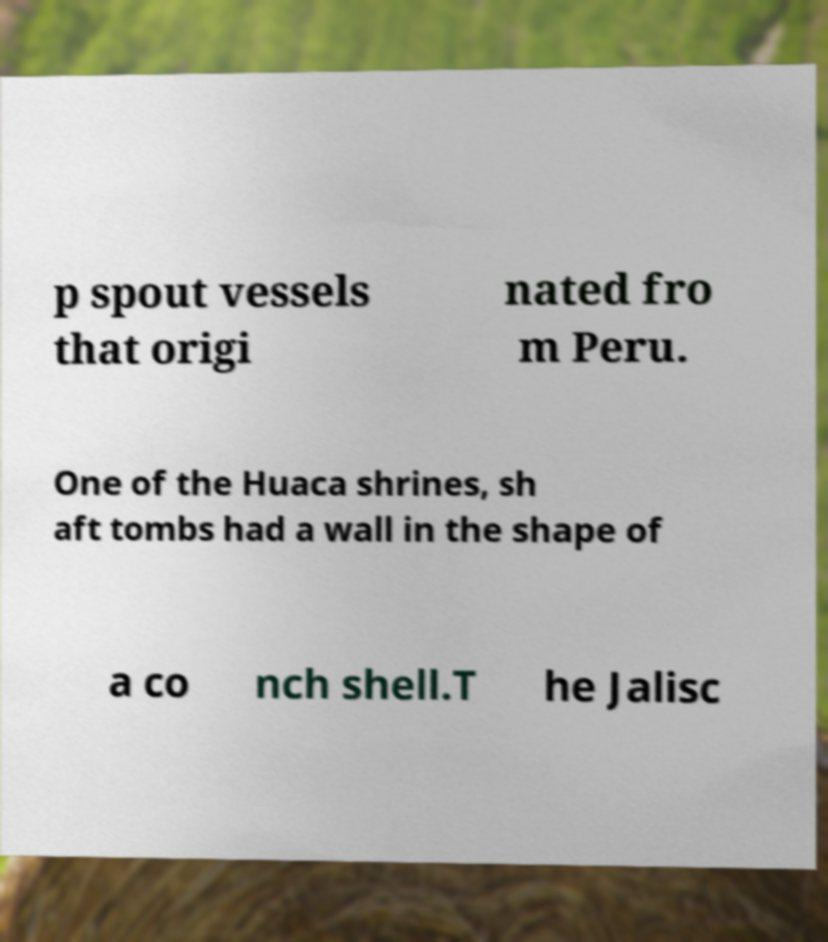There's text embedded in this image that I need extracted. Can you transcribe it verbatim? p spout vessels that origi nated fro m Peru. One of the Huaca shrines, sh aft tombs had a wall in the shape of a co nch shell.T he Jalisc 